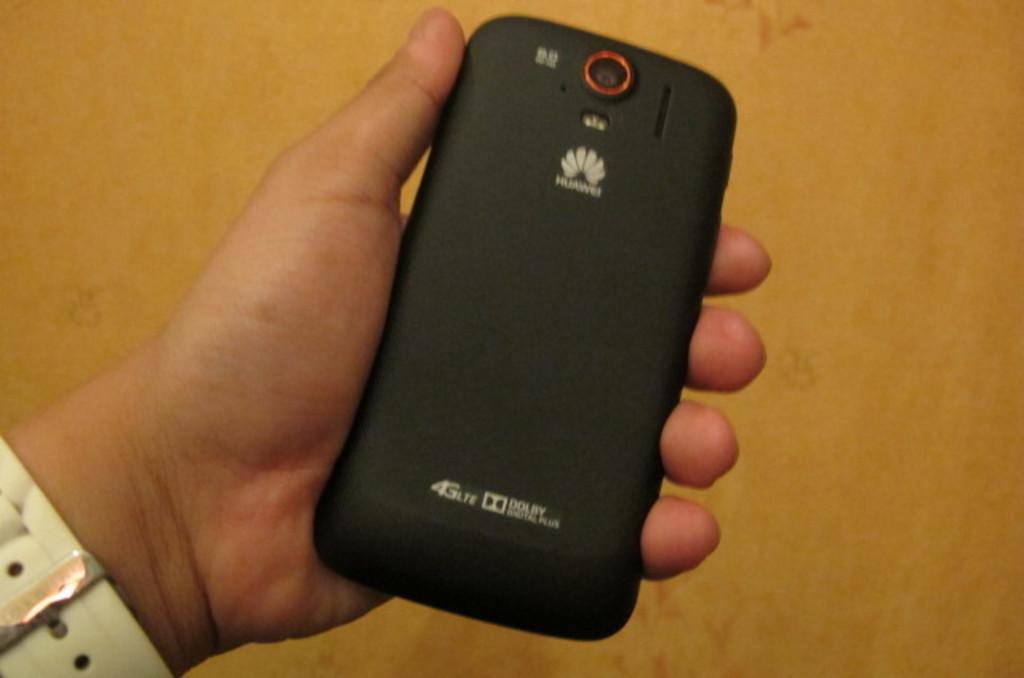What is the brand of this phone?
Give a very brief answer. Huawei. What company provided the speaker on this phone?
Your answer should be compact. Dolby. 